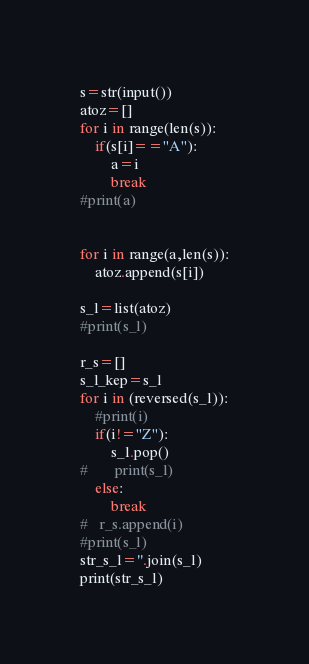Convert code to text. <code><loc_0><loc_0><loc_500><loc_500><_Python_>
s=str(input())
atoz=[]
for i in range(len(s)):
	if(s[i]=="A"):
		a=i
		break
#print(a)


for i in range(a,len(s)):
	atoz.append(s[i])

s_l=list(atoz)
#print(s_l)

r_s=[]
s_l_kep=s_l
for i in (reversed(s_l)):
	#print(i)
	if(i!="Z"):
		s_l.pop()
#		print(s_l)
	else:
		break
#	r_s.append(i)
#print(s_l)
str_s_l=''.join(s_l)
print(str_s_l)</code> 